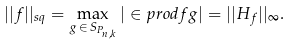<formula> <loc_0><loc_0><loc_500><loc_500>| | f | | _ { s q } = \max _ { g \, \in \, S _ { P _ { n , k } } } | \in p r o d { f } { g } | = | | H _ { f } | | _ { \infty } .</formula> 